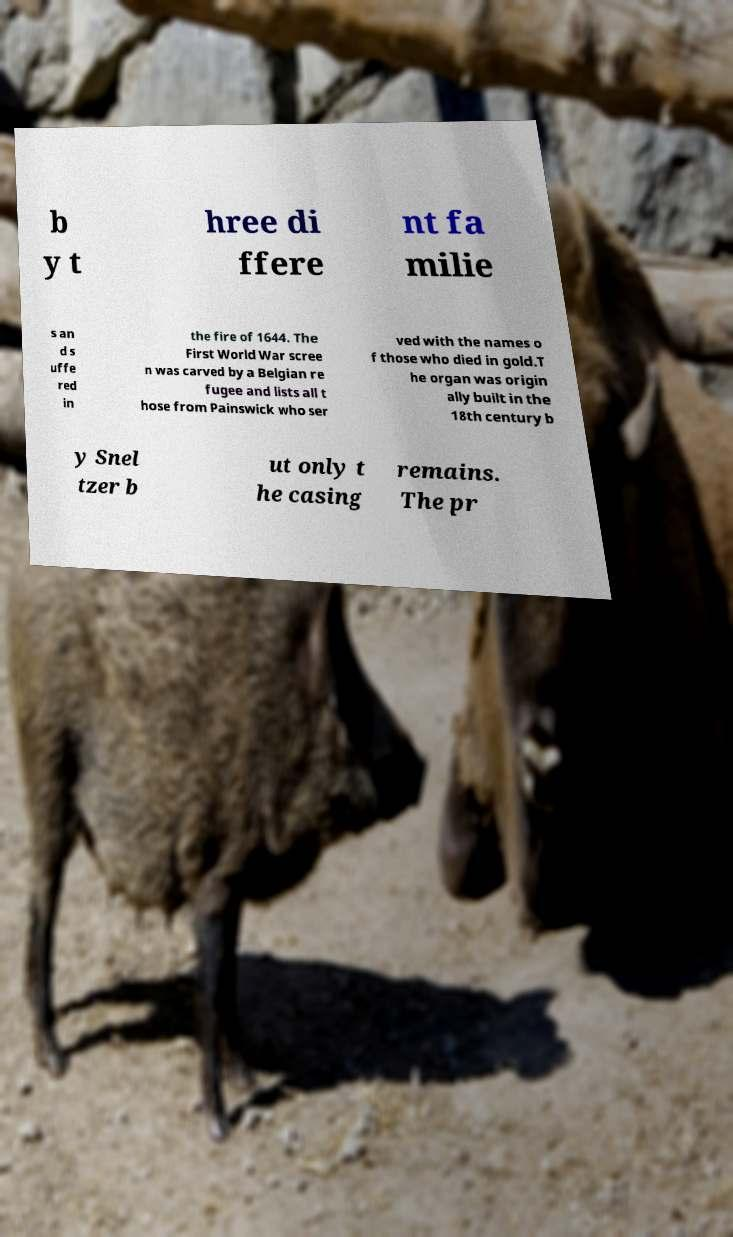Please read and relay the text visible in this image. What does it say? b y t hree di ffere nt fa milie s an d s uffe red in the fire of 1644. The First World War scree n was carved by a Belgian re fugee and lists all t hose from Painswick who ser ved with the names o f those who died in gold.T he organ was origin ally built in the 18th century b y Snel tzer b ut only t he casing remains. The pr 